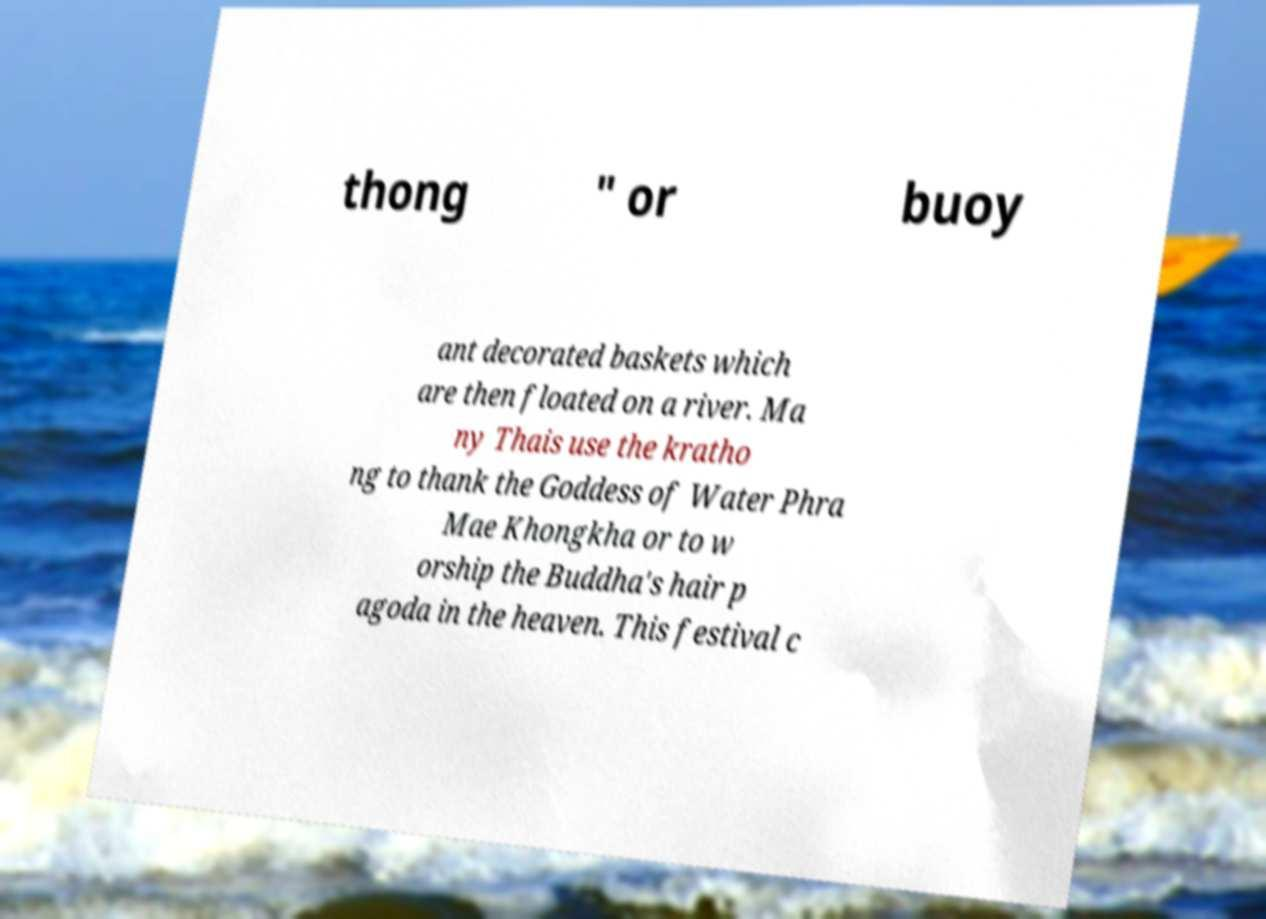I need the written content from this picture converted into text. Can you do that? thong " or buoy ant decorated baskets which are then floated on a river. Ma ny Thais use the kratho ng to thank the Goddess of Water Phra Mae Khongkha or to w orship the Buddha's hair p agoda in the heaven. This festival c 